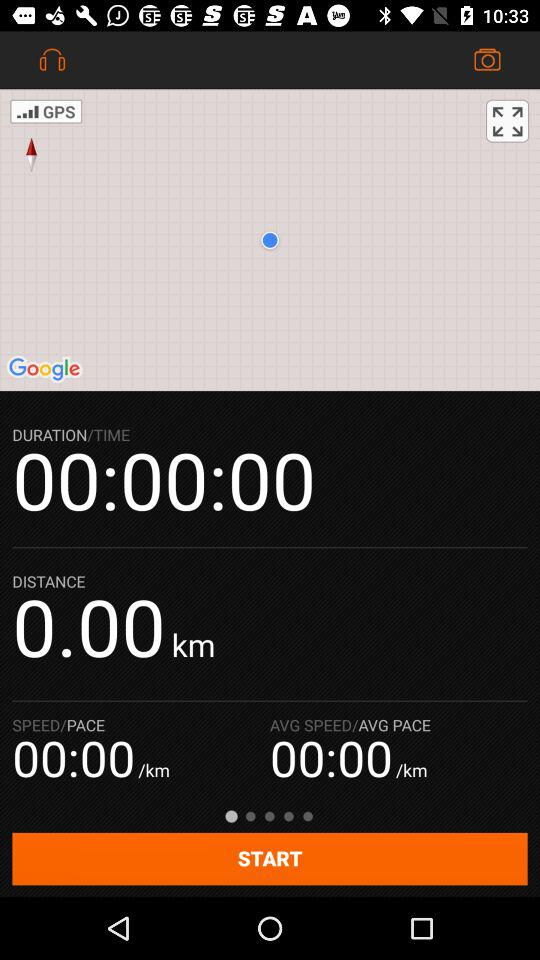How long has the activity been going on for?
Answer the question using a single word or phrase. 00:00:00 